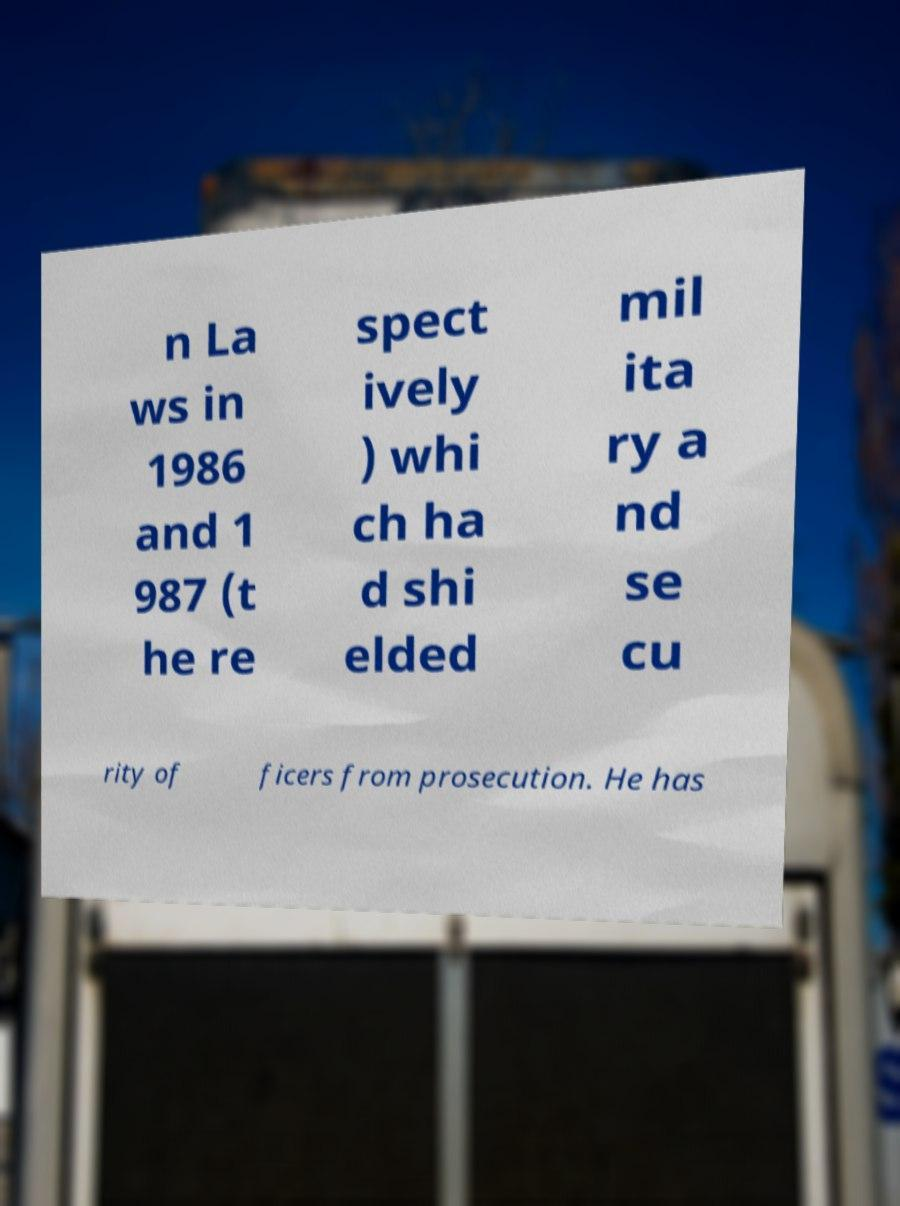Please identify and transcribe the text found in this image. n La ws in 1986 and 1 987 (t he re spect ively ) whi ch ha d shi elded mil ita ry a nd se cu rity of ficers from prosecution. He has 